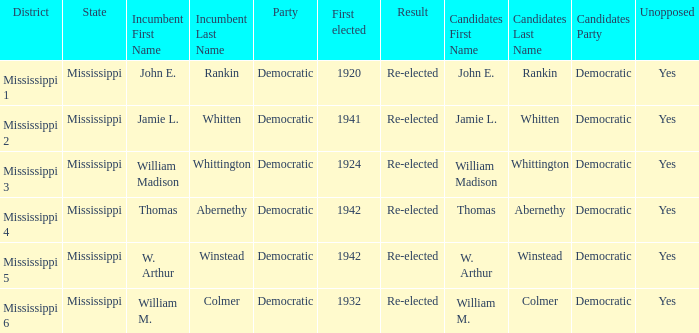What candidates are from mississippi 6? William M. Colmer (D) Unopposed. 